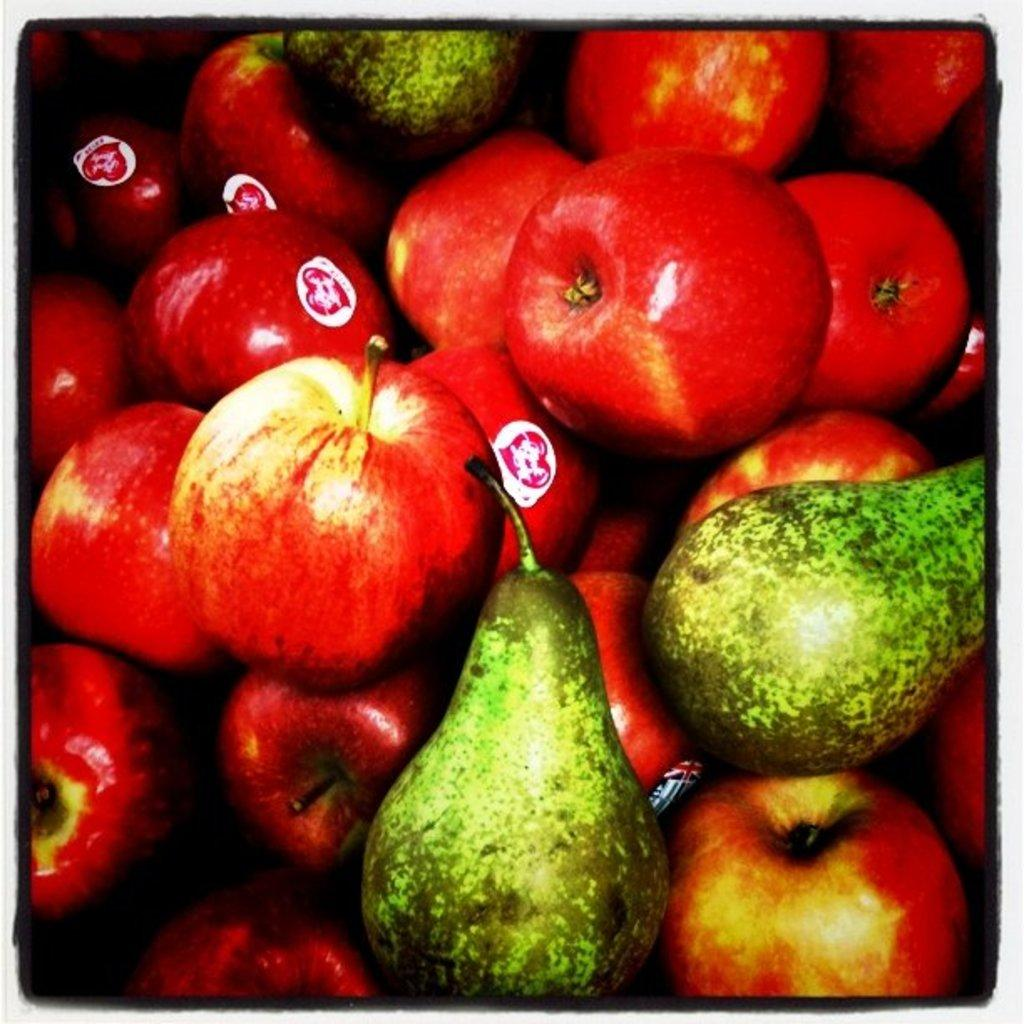What types of food are present in the image? There are many types of fruits in the image. How many women are holding a tooth in the image? There are no women or teeth present in the image; it features many types of fruits. 